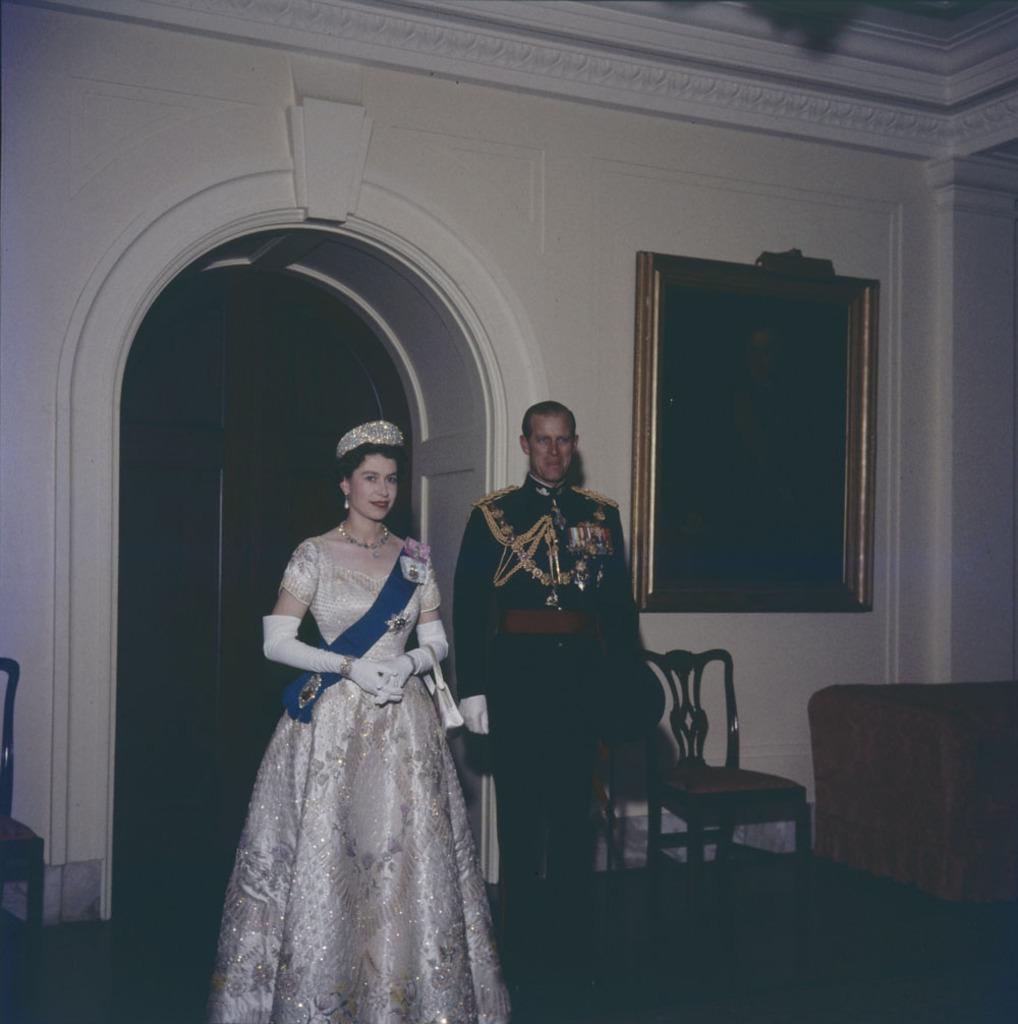Can you describe this image briefly? In this picture there are two guys. In the background there is a wooden door. To the left of the image there is a chair and a sofa. 